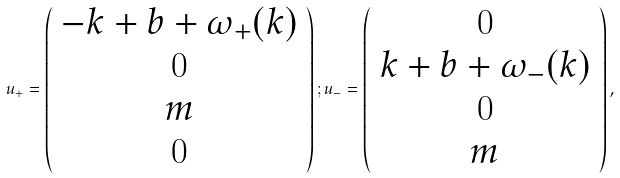Convert formula to latex. <formula><loc_0><loc_0><loc_500><loc_500>u _ { + } = \left ( \begin{array} { c } - k + b + \omega _ { + } ( k ) \\ 0 \\ m \\ 0 \end{array} \right ) ; u _ { - } = \left ( \begin{array} { c } 0 \\ k + b + \omega _ { - } ( k ) \\ 0 \\ m \end{array} \right ) ,</formula> 